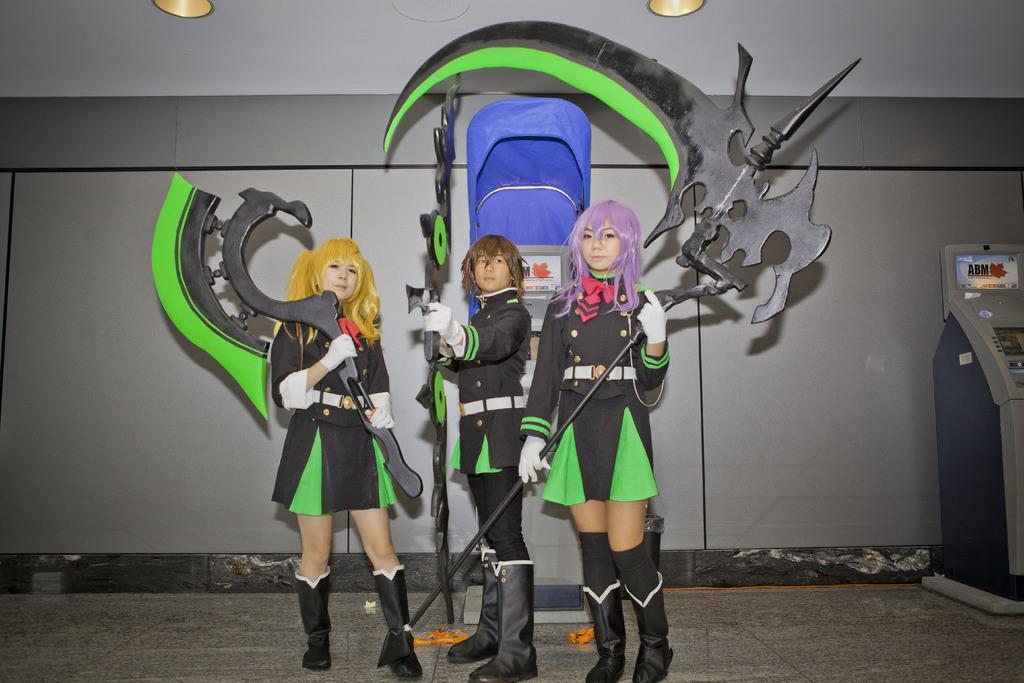In one or two sentences, can you explain what this image depicts? This image consists of three persons wearing costumes. At the bottom, there is a ground. To the right, there is a machine. In the background, there is a wall. To the top, there are lights. 